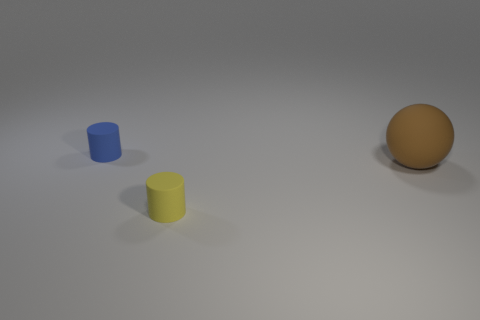What color is the other matte thing that is the same size as the blue matte object?
Give a very brief answer. Yellow. Do the blue rubber cylinder and the yellow rubber cylinder have the same size?
Make the answer very short. Yes. What is the size of the rubber thing that is both left of the brown thing and behind the small yellow thing?
Your response must be concise. Small. What number of metal objects are either spheres or green cylinders?
Offer a very short reply. 0. Are there more small yellow matte cylinders that are to the right of the blue object than objects?
Keep it short and to the point. No. There is a small thing to the left of the tiny yellow rubber thing; what is it made of?
Offer a terse response. Rubber. What number of big brown things have the same material as the yellow object?
Keep it short and to the point. 1. What shape is the object that is to the right of the blue rubber cylinder and on the left side of the big rubber thing?
Offer a terse response. Cylinder. What number of things are either tiny rubber objects on the right side of the blue matte thing or matte cylinders that are in front of the large brown matte thing?
Offer a terse response. 1. Are there an equal number of tiny yellow rubber cylinders to the right of the big matte sphere and brown things that are left of the tiny yellow cylinder?
Provide a short and direct response. Yes. 